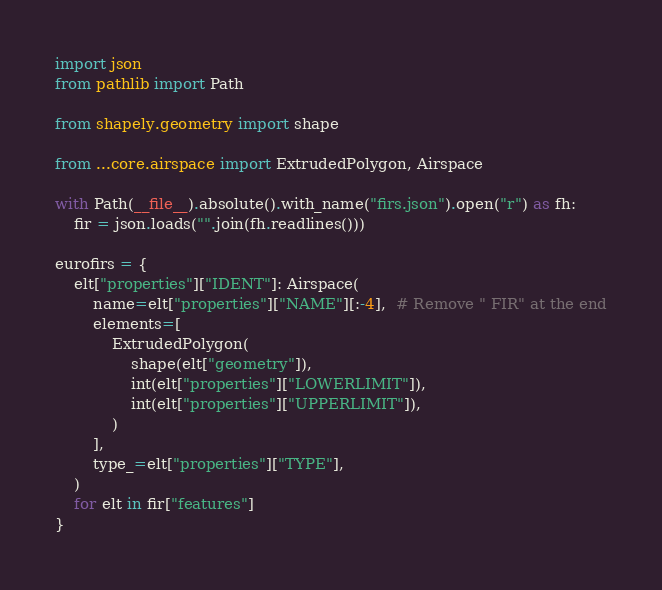<code> <loc_0><loc_0><loc_500><loc_500><_Python_>import json
from pathlib import Path

from shapely.geometry import shape

from ...core.airspace import ExtrudedPolygon, Airspace

with Path(__file__).absolute().with_name("firs.json").open("r") as fh:
    fir = json.loads("".join(fh.readlines()))

eurofirs = {
    elt["properties"]["IDENT"]: Airspace(
        name=elt["properties"]["NAME"][:-4],  # Remove " FIR" at the end
        elements=[
            ExtrudedPolygon(
                shape(elt["geometry"]),
                int(elt["properties"]["LOWERLIMIT"]),
                int(elt["properties"]["UPPERLIMIT"]),
            )
        ],
        type_=elt["properties"]["TYPE"],
    )
    for elt in fir["features"]
}
</code> 